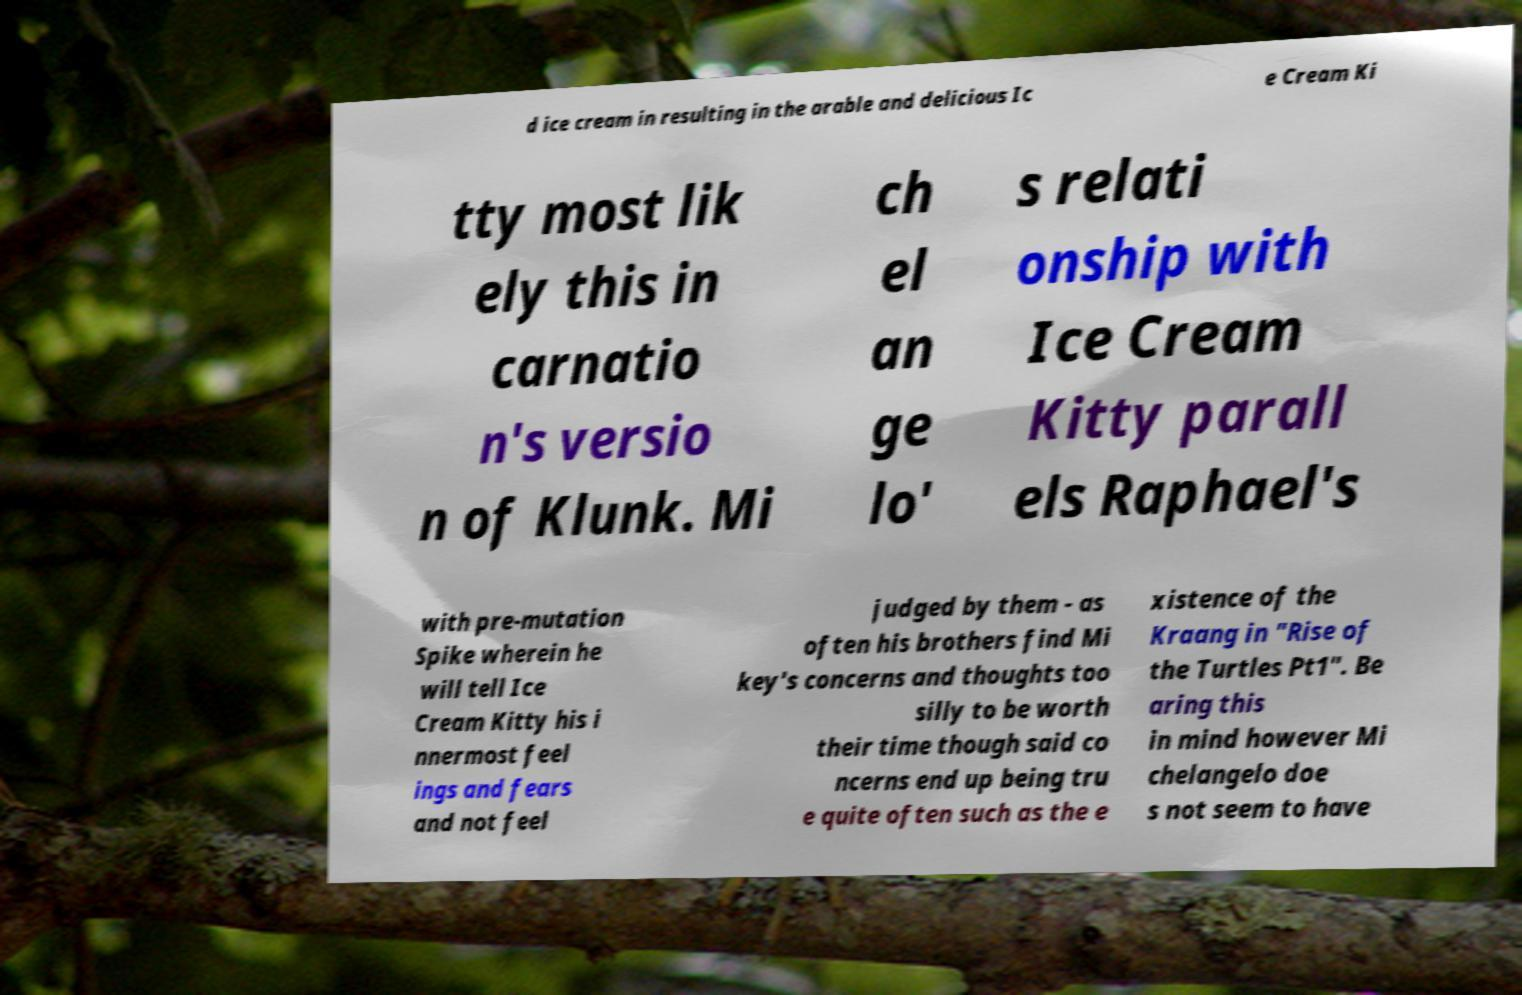Can you read and provide the text displayed in the image?This photo seems to have some interesting text. Can you extract and type it out for me? d ice cream in resulting in the arable and delicious Ic e Cream Ki tty most lik ely this in carnatio n's versio n of Klunk. Mi ch el an ge lo' s relati onship with Ice Cream Kitty parall els Raphael's with pre-mutation Spike wherein he will tell Ice Cream Kitty his i nnermost feel ings and fears and not feel judged by them - as often his brothers find Mi key's concerns and thoughts too silly to be worth their time though said co ncerns end up being tru e quite often such as the e xistence of the Kraang in "Rise of the Turtles Pt1". Be aring this in mind however Mi chelangelo doe s not seem to have 